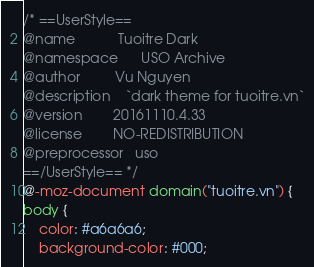<code> <loc_0><loc_0><loc_500><loc_500><_CSS_>/* ==UserStyle==
@name           Tuoitre Dark
@namespace      USO Archive
@author         Vu Nguyen
@description    `dark theme for tuoitre.vn`
@version        20161110.4.33
@license        NO-REDISTRIBUTION
@preprocessor   uso
==/UserStyle== */
@-moz-document domain("tuoitre.vn") {
body {
    color: #a6a6a6;
    background-color: #000;</code> 